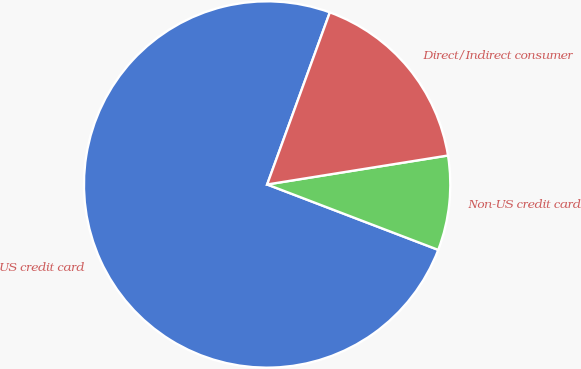<chart> <loc_0><loc_0><loc_500><loc_500><pie_chart><fcel>US credit card<fcel>Non-US credit card<fcel>Direct/Indirect consumer<nl><fcel>74.75%<fcel>8.34%<fcel>16.91%<nl></chart> 